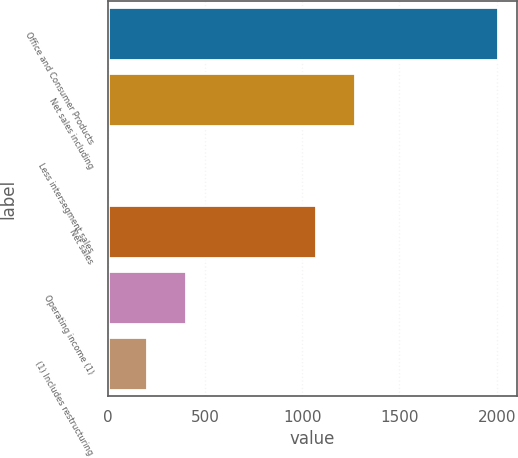<chart> <loc_0><loc_0><loc_500><loc_500><bar_chart><fcel>Office and Consumer Products<fcel>Net sales including<fcel>Less intersegment sales<fcel>Net sales<fcel>Operating income (1)<fcel>(1) Includes restructuring<nl><fcel>2006<fcel>1272.42<fcel>1.8<fcel>1072<fcel>402.64<fcel>202.22<nl></chart> 